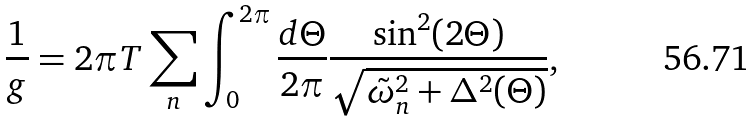Convert formula to latex. <formula><loc_0><loc_0><loc_500><loc_500>\frac { 1 } { g } = 2 \pi T \sum _ { n } \int _ { 0 } ^ { 2 \pi } \frac { d \Theta } { 2 \pi } \frac { \sin ^ { 2 } ( 2 \Theta ) } { \sqrt { \tilde { \omega } _ { n } ^ { 2 } + \Delta ^ { 2 } ( \Theta ) } } ,</formula> 